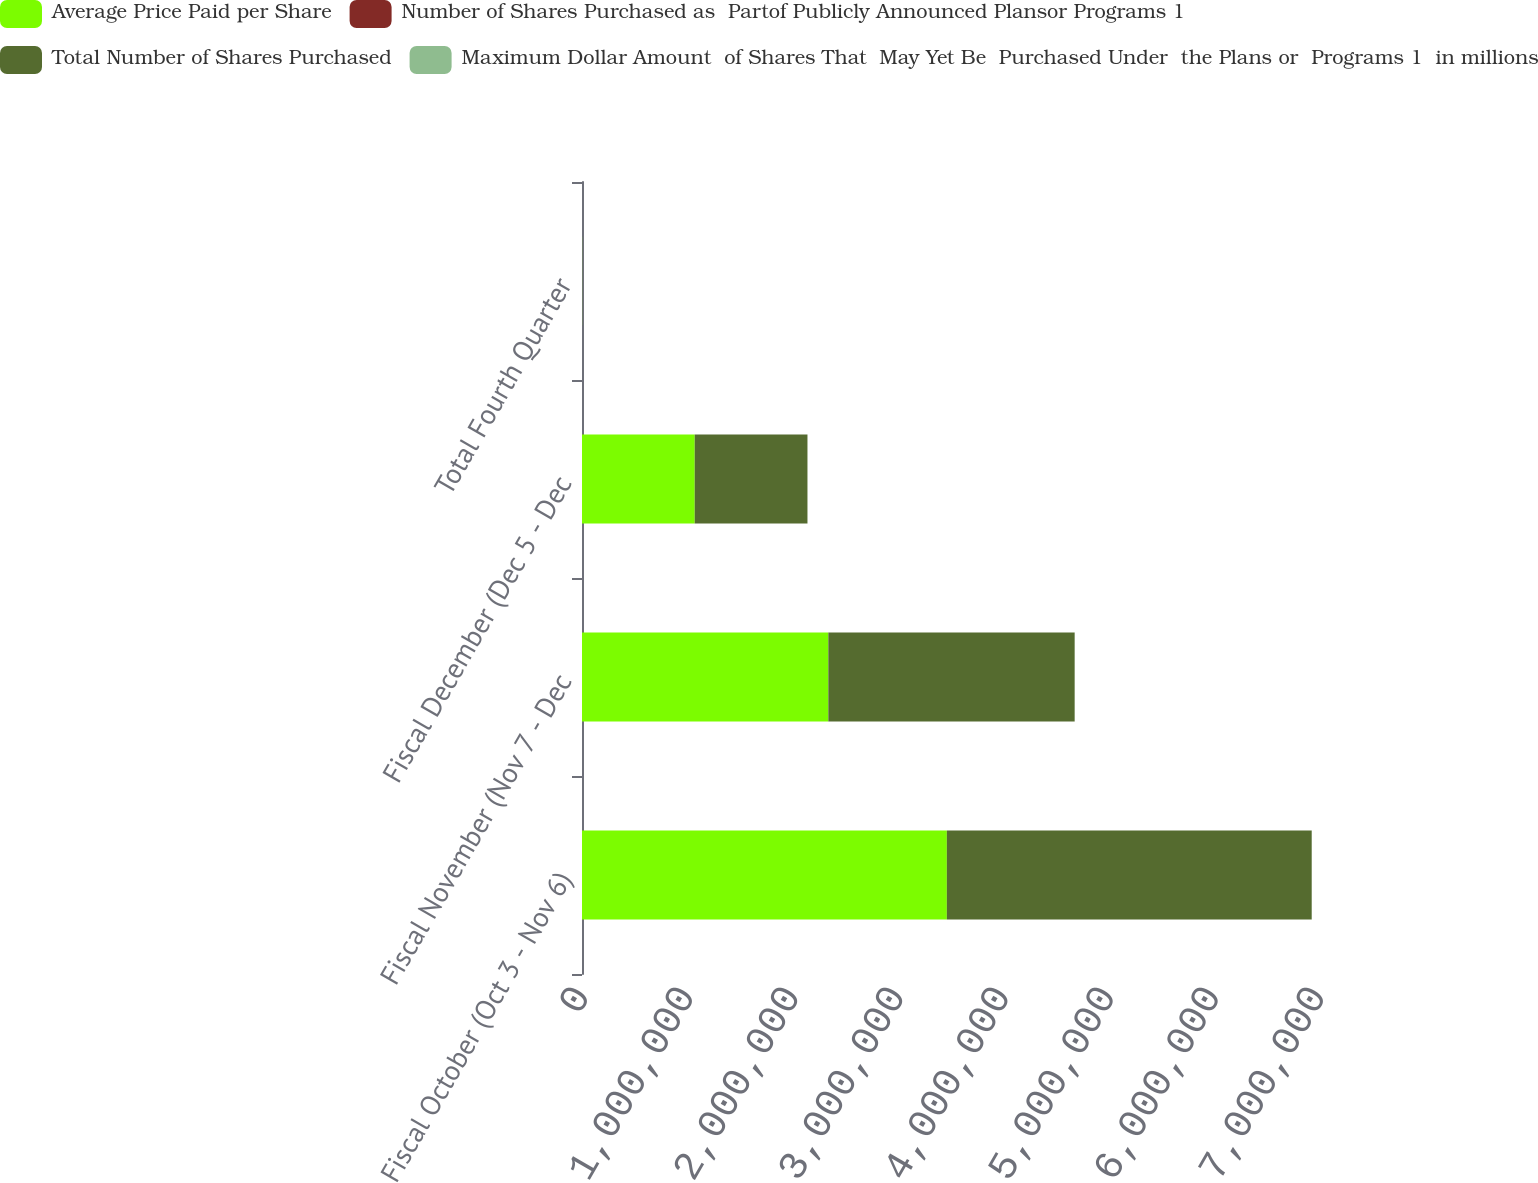Convert chart. <chart><loc_0><loc_0><loc_500><loc_500><stacked_bar_chart><ecel><fcel>Fiscal October (Oct 3 - Nov 6)<fcel>Fiscal November (Nov 7 - Dec<fcel>Fiscal December (Dec 5 - Dec<fcel>Total Fourth Quarter<nl><fcel>Average Price Paid per Share<fcel>3.4701e+06<fcel>2.34282e+06<fcel>1.07214e+06<fcel>605.45<nl><fcel>Number of Shares Purchased as  Partof Publicly Announced Plansor Programs 1<fcel>49.49<fcel>51.51<fcel>53.7<fcel>50.83<nl><fcel>Total Number of Shares Purchased<fcel>3.4701e+06<fcel>2.34282e+06<fcel>1.07214e+06<fcel>605.45<nl><fcel>Maximum Dollar Amount  of Shares That  May Yet Be  Purchased Under  the Plans or  Programs 1  in millions<fcel>665.8<fcel>545.1<fcel>487.5<fcel>487.5<nl></chart> 